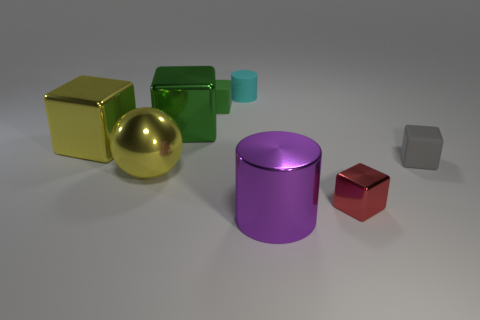There is a large shiny thing that is the same color as the big metallic ball; what is its shape?
Give a very brief answer. Cube. Do the tiny cyan thing and the block to the right of the red cube have the same material?
Provide a short and direct response. Yes. What is the color of the shiny cube that is the same size as the cyan thing?
Offer a very short reply. Red. What is the size of the cube that is in front of the small rubber cube right of the big cylinder?
Provide a short and direct response. Small. Is the color of the rubber cylinder the same as the large thing that is to the right of the cyan matte cylinder?
Make the answer very short. No. Is the number of spheres that are in front of the yellow metal ball less than the number of cyan rubber balls?
Keep it short and to the point. No. What number of other things are the same size as the purple shiny thing?
Offer a terse response. 3. There is a tiny object on the left side of the small cyan thing; is it the same shape as the large purple object?
Your answer should be compact. No. Is the number of purple cylinders on the left side of the large green block greater than the number of big purple metallic cylinders?
Provide a succinct answer. No. What material is the block that is both behind the large metallic sphere and right of the cyan matte thing?
Provide a succinct answer. Rubber. 